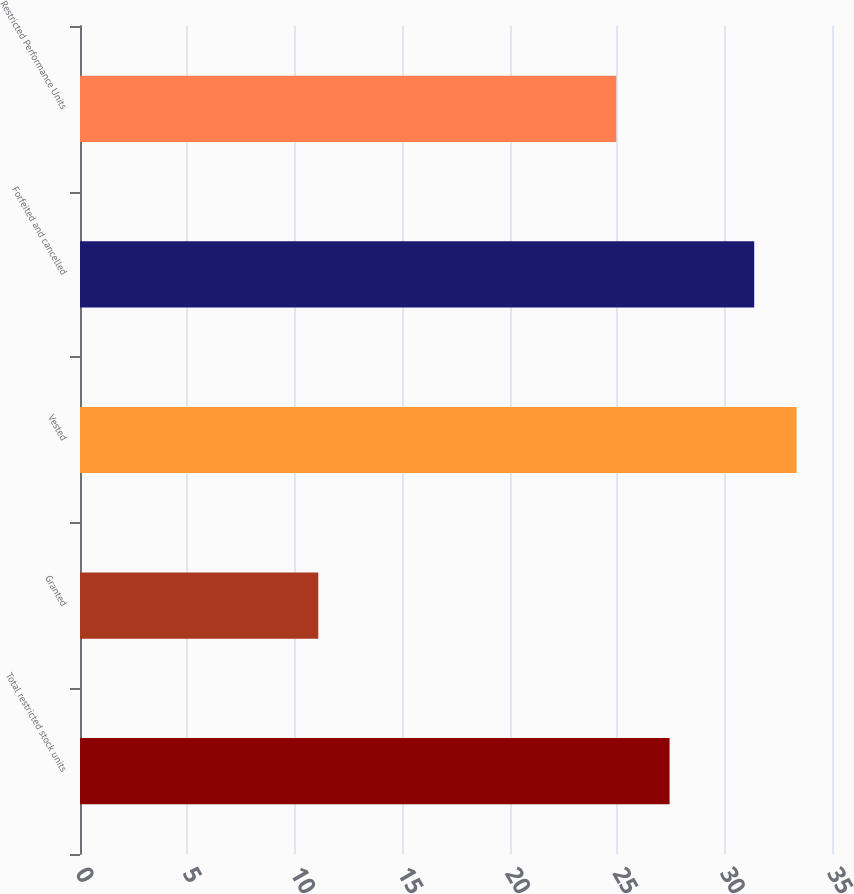Convert chart. <chart><loc_0><loc_0><loc_500><loc_500><bar_chart><fcel>Total restricted stock units<fcel>Granted<fcel>Vested<fcel>Forfeited and cancelled<fcel>Restricted Performance Units<nl><fcel>27.44<fcel>11.09<fcel>33.35<fcel>31.38<fcel>24.96<nl></chart> 